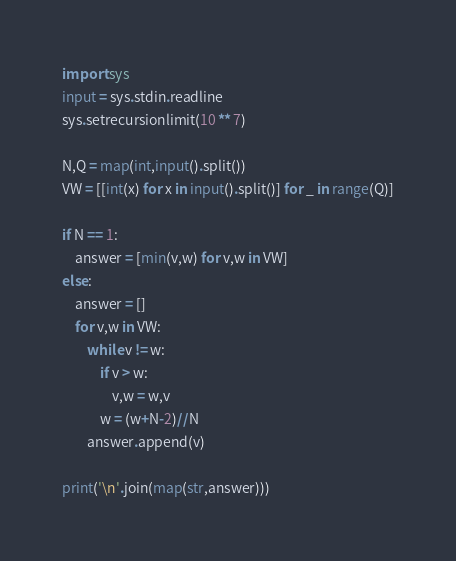<code> <loc_0><loc_0><loc_500><loc_500><_Python_>import sys
input = sys.stdin.readline
sys.setrecursionlimit(10 ** 7)

N,Q = map(int,input().split())
VW = [[int(x) for x in input().split()] for _ in range(Q)]

if N == 1:
    answer = [min(v,w) for v,w in VW]
else:
    answer = []
    for v,w in VW:
        while v != w:
            if v > w:
                v,w = w,v
            w = (w+N-2)//N
        answer.append(v)

print('\n'.join(map(str,answer)))</code> 